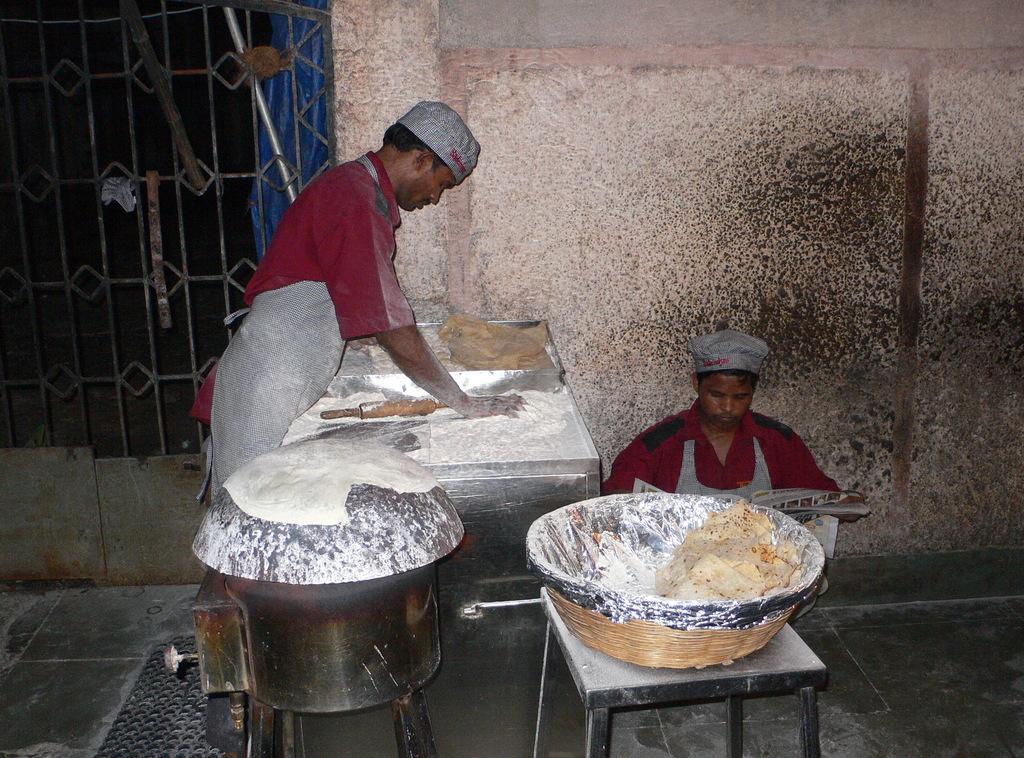Could you give a brief overview of what you see in this image? In the image there is a stool. On the stool there is a basket with silver cover and some food items in it. Beside that there is a stove with pan. On the pan there is an object. Behind the stove there's a man with cap and apron is standing. In front of him there is a table with flour and wooden roll. Behind the table there is a man on the floor. Behind them there is a wall and grills with designs. And also there are few items in it. 